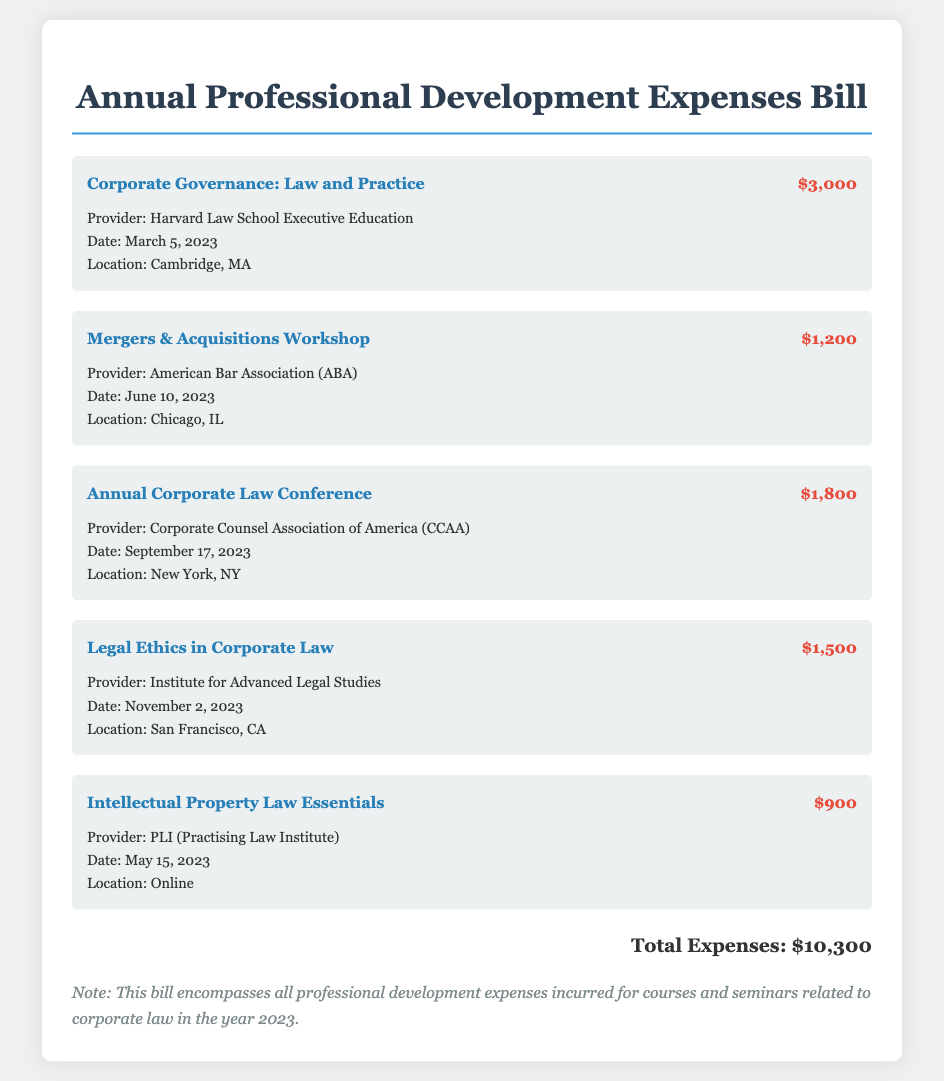What is the total expenses amount? The total expenses amount is stated at the end of the document and is the sum of all the individual expense items listed.
Answer: $10,300 Who provided the Corporate Governance course? The provider of the Corporate Governance course is noted in the details of that expense item.
Answer: Harvard Law School Executive Education What date was the Mergers & Acquisitions Workshop held? The date of the Mergers & Acquisitions Workshop is provided in the expense details for that event.
Answer: June 10, 2023 How much did the Annual Corporate Law Conference cost? The cost is specified next to the title of the Annual Corporate Law Conference in the document.
Answer: $1,800 Where was the Legal Ethics in Corporate Law seminar located? The location for the Legal Ethics in Corporate Law seminar is indicated in its respective expense details.
Answer: San Francisco, CA How many expense items are listed in total? The number of expense items can be counted based on the distinct expense entries provided in the document.
Answer: 5 What is the provider for the Intellectual Property Law Essentials course? The provider's name is clearly mentioned in the details of the Intellectual Property Law Essentials expense item.
Answer: PLI (Practising Law Institute) On what date is the next seminar after the Annual Corporate Law Conference? The date of the next seminar is found in the details of the upcoming event listed after the Annual Corporate Law Conference.
Answer: November 2, 2023 